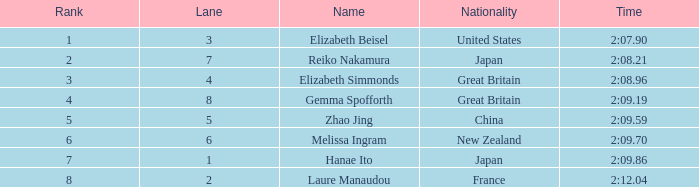What is elizabeth simmonds' mean lane number? 4.0. 